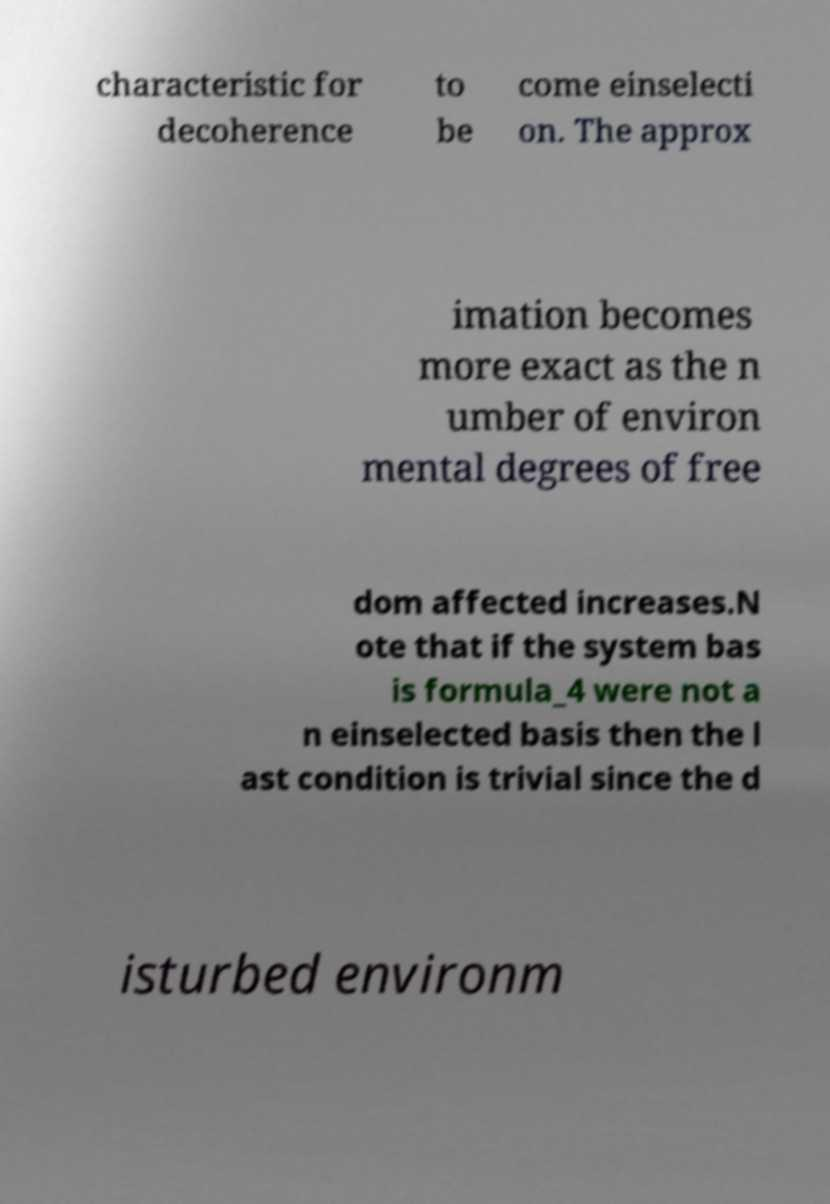For documentation purposes, I need the text within this image transcribed. Could you provide that? characteristic for decoherence to be come einselecti on. The approx imation becomes more exact as the n umber of environ mental degrees of free dom affected increases.N ote that if the system bas is formula_4 were not a n einselected basis then the l ast condition is trivial since the d isturbed environm 